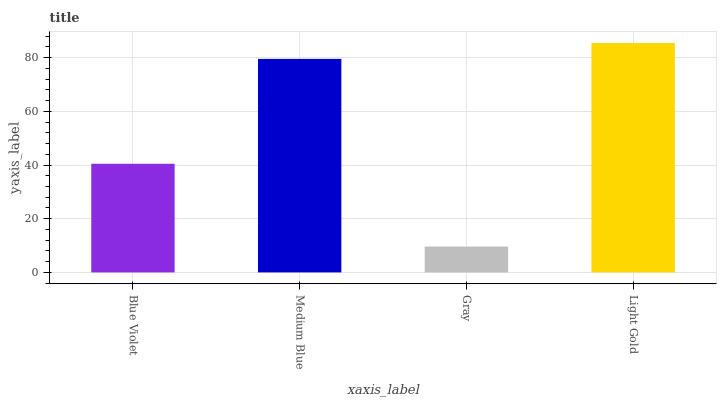Is Gray the minimum?
Answer yes or no. Yes. Is Light Gold the maximum?
Answer yes or no. Yes. Is Medium Blue the minimum?
Answer yes or no. No. Is Medium Blue the maximum?
Answer yes or no. No. Is Medium Blue greater than Blue Violet?
Answer yes or no. Yes. Is Blue Violet less than Medium Blue?
Answer yes or no. Yes. Is Blue Violet greater than Medium Blue?
Answer yes or no. No. Is Medium Blue less than Blue Violet?
Answer yes or no. No. Is Medium Blue the high median?
Answer yes or no. Yes. Is Blue Violet the low median?
Answer yes or no. Yes. Is Blue Violet the high median?
Answer yes or no. No. Is Gray the low median?
Answer yes or no. No. 